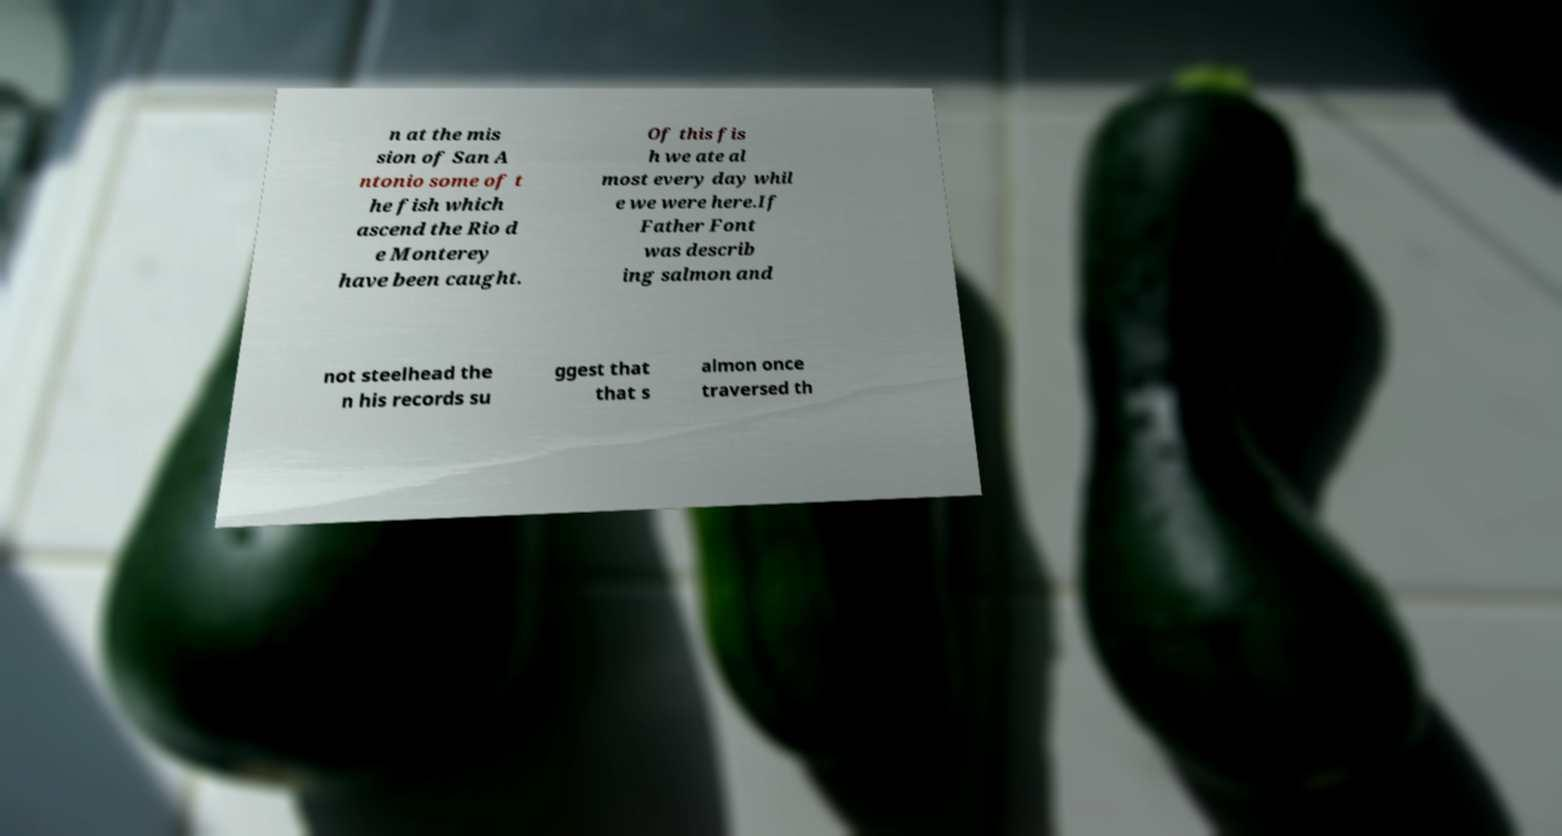Could you extract and type out the text from this image? n at the mis sion of San A ntonio some of t he fish which ascend the Rio d e Monterey have been caught. Of this fis h we ate al most every day whil e we were here.If Father Font was describ ing salmon and not steelhead the n his records su ggest that that s almon once traversed th 